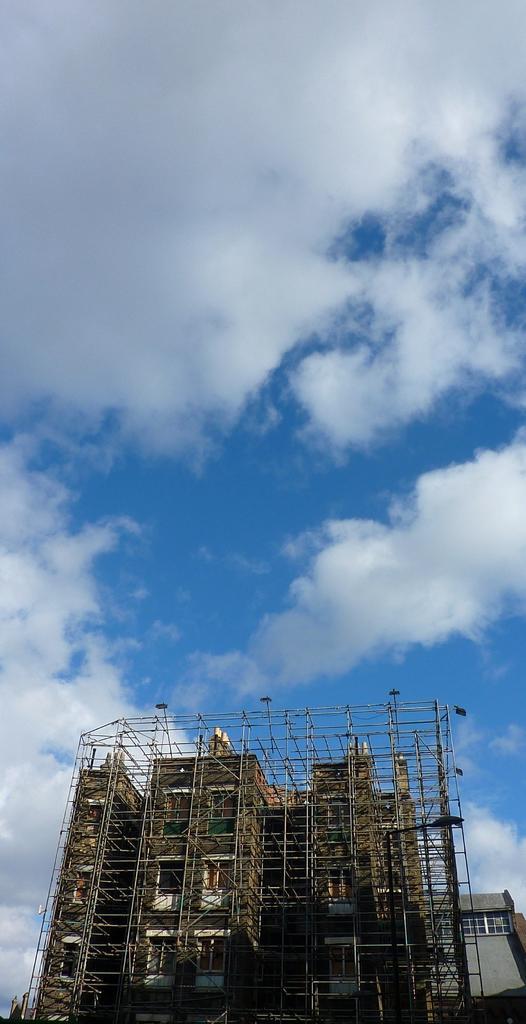In one or two sentences, can you explain what this image depicts? In this image there is an under construction building, a house behind it and some clouds in the clouds. 